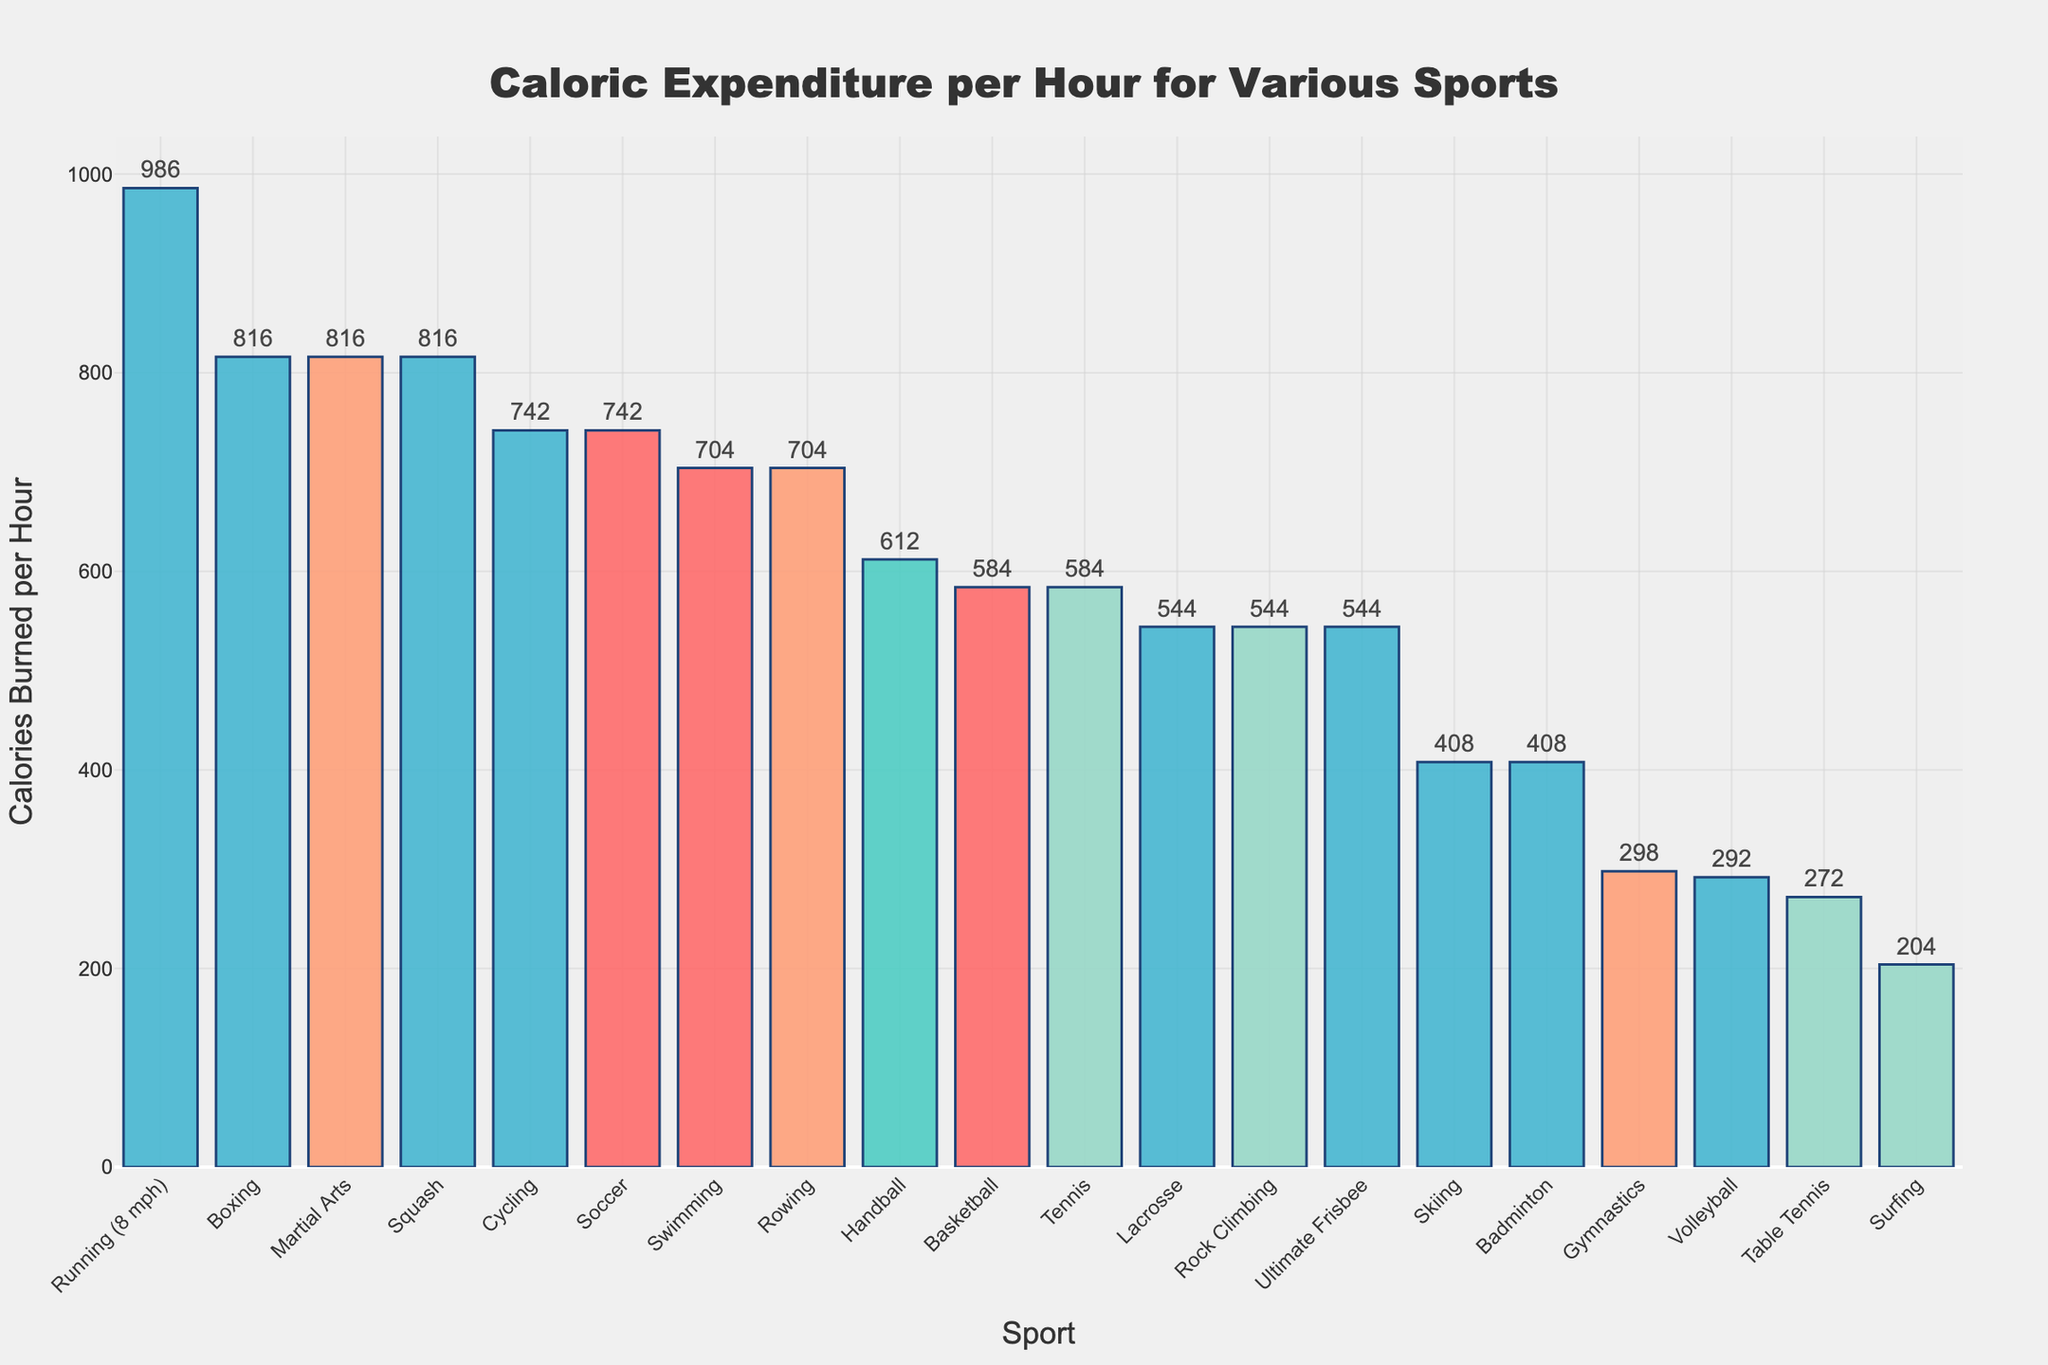Which sport burns the most calories per hour? Running (8 mph) has the highest bar among all sports, indicating it burns the most calories per hour, which is 986 calories.
Answer: Running (8 mph) Which sports burn exactly 816 calories per hour? The bars corresponding to Boxing, Squash, and Martial Arts all reach the same height, showing they each burn 816 calories per hour.
Answer: Boxing, Squash, Martial Arts How much of a difference is there in calories burned per hour between Volleyball and Cycling? According to the chart, Volleyball burns 292 calories per hour and Cycling burns 742 calories per hour. The difference is 742 - 292 = 450 calories.
Answer: 450 calories What is the average caloric expenditure for Swimming, Rowing, and Cycling? Swimming burns 704 calories, Rowing burns 704 calories, and Cycling burns 742 calories per hour. Average = (704 + 704 + 742) / 3 = 2150 / 3 ≈ 716.67 calories.
Answer: 716.67 calories Which sport burns fewer calories per hour, Badminton or Gymnastics? The bar for Badminton is higher than the bar for Gymnastics, meaning Badminton burns more calories per hour. Therefore, Gymnastics burns fewer calories.
Answer: Gymnastics Compare the caloric expenditure in Soccer, Basketball, and Table Tennis. Which one burns the least calories per hour? Table Tennis has the shortest bar among the three, indicating it burns the least calories per hour (272 calories). Basketball burns 584 calories and Soccer burns 742 calories.
Answer: Table Tennis How many sports have a caloric expenditure greater than 700 calories per hour? The bars for Running (8 mph), Soccer, Swimming, Cycling, Rowing, Boxing, Squash, and Martial Arts are all above the 700-calorie mark, making it a total of 8 sports.
Answer: 8 sports What is the caloric expenditure difference between the sport with the highest expenditure and the sport with the lowest expenditure? Running (8 mph) burns 986 calories per hour, while Surfing burns 204 calories per hour. The difference is 986 - 204 = 782 calories.
Answer: 782 calories If you combine the caloric expenditures of Tennis, Skiing, and Rock Climbing, what is the total expenditure? Tennis burns 584 calories, Skiing burns 408 calories, and Rock Climbing burns 544 calories per hour. Total expenditure = 584 + 408 + 544 = 1536 calories.
Answer: 1536 calories 